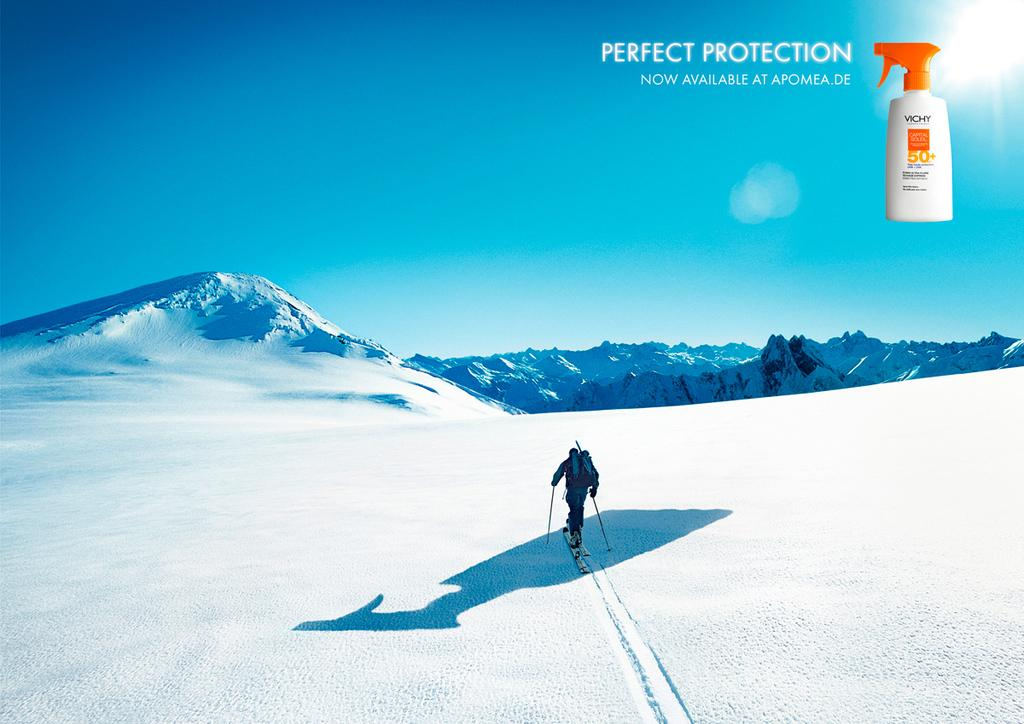<image>
Provide a brief description of the given image. An advertisement for sunscreen by Vichy features a skiier on a snowy mountain. 